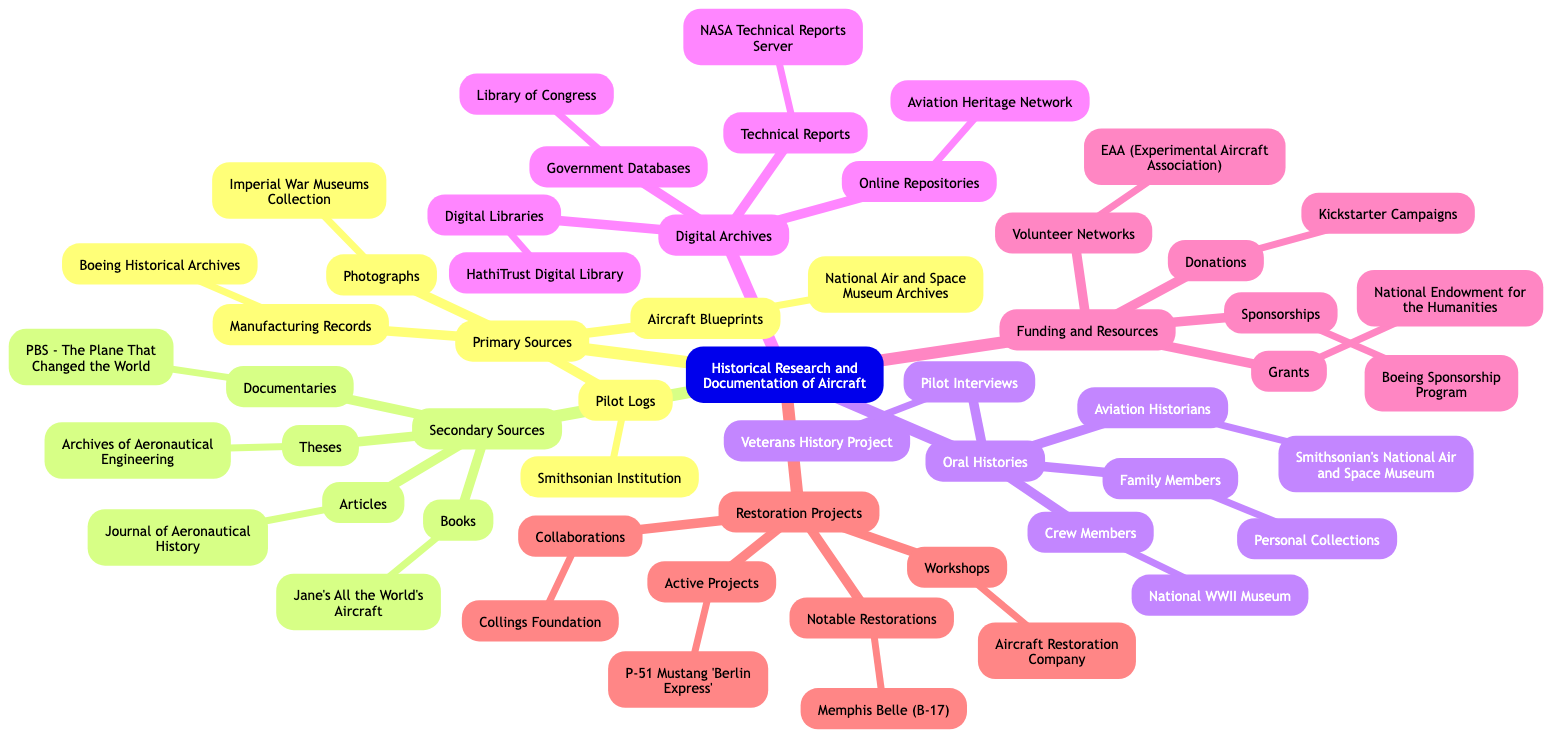What are the four primary sources listed in the diagram? The diagram shows four primary sources under the "Primary Sources" node: "Aircraft Blueprints," "Pilot Logs," "Manufacturing Records," and "Photographs."
Answer: Aircraft Blueprints, Pilot Logs, Manufacturing Records, Photographs How many secondary sources are mentioned? The diagram contains four secondary sources: "Books," "Articles," "Theses," and "Documentaries." This is determined by counting each of the sources listed under the "Secondary Sources" node.
Answer: 4 Which museum is associated with the Pilot Interviews oral history? The "Pilot Interviews" node under "Oral Histories" links to the "Veterans History Project." This connection is established by following the "Pilot Interviews" node to its corresponding source.
Answer: Veterans History Project What is the notable restoration project mentioned in the diagram? The diagram highlights the "Memphis Belle (B-17)" under the "Notable Restorations" node in the "Restoration Projects" section. This can be found by looking specifically within the restoration section of the mind map.
Answer: Memphis Belle (B-17) Which entity provides grants as a funding resource? The "Grants" node under the "Funding and Resources" section specifies "National Endowment for the Humanities" as the source for grants. This is identified by navigating to the funding category and checking the grants subsection.
Answer: National Endowment for the Humanities What type of oral history is linked to the National WWII Museum? The "Crew Members" node under the "Oral Histories" section indicates that it is linked to the "National WWII Museum." This can be traced by examining the oral histories for crew members.
Answer: National WWII Museum What is the governmental source for digital archives? The "Government Databases" node lists the "Library of Congress" as the source in the "Digital Archives" section. This can be found by following the digital archives category to its governmental reference.
Answer: Library of Congress How many active projects are listed in the restoration projects? The diagram shows one active project mentioned: "P-51 Mustang 'Berlin Express.'" This is identified by looking under the "Active Projects" node in the restoration projects area.
Answer: 1 